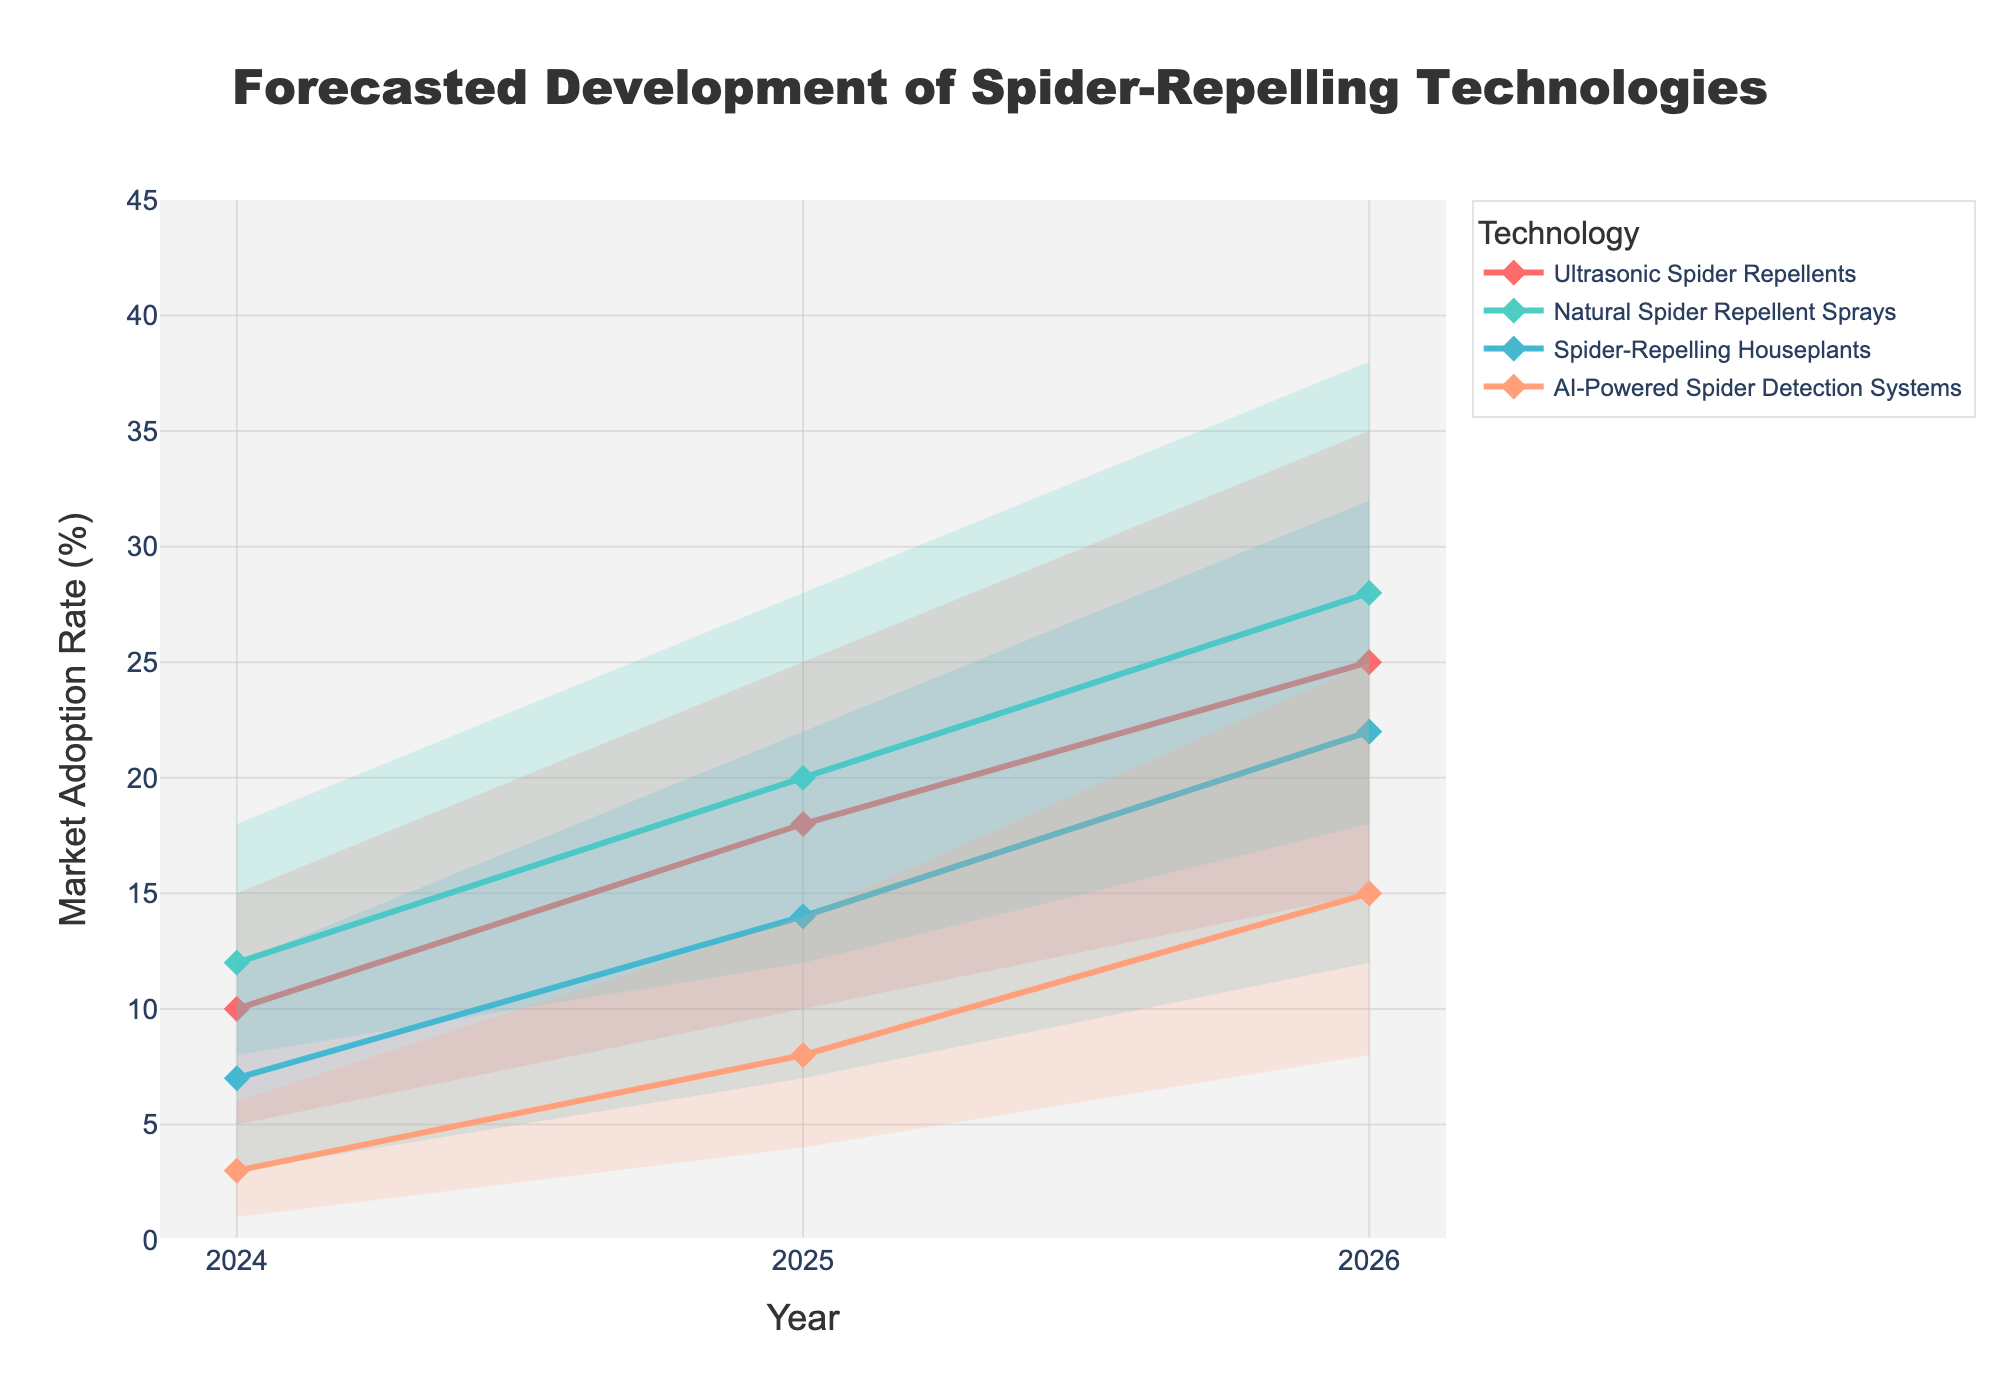What is the highest market adoption rate projected for Ultrasonic Spider Repellents in 2026? The highest market adoption rate for Ultrasonic Spider Repellents in 2026 corresponds to the "High Estimate" value for that technology in that year. From the data, this value is 35%.
Answer: 35% What is the range of market adoption rates for Spider-Repelling Houseplants in 2025? The range of market adoption rates is found by subtracting the Low Estimate from the High Estimate for Spider-Repelling Houseplants in 2025. The values are 22% (High Estimate) and 7% (Low Estimate). Thus, 22% - 7% = 15%.
Answer: 15% Which technology has the lowest Mid Estimate for market adoption in 2024? To determine which technology has the lowest Mid Estimate for market adoption in 2024, compare the Mid Estimates of all technologies in that year. AI-Powered Spider Detection Systems have a Mid Estimate of 3%, which is the lowest among the listed technologies.
Answer: AI-Powered Spider Detection Systems Between which two years does the Mid Estimate for Natural Spider Repellent Sprays show the greatest increase? Calculate the increase in Mid Estimates for Natural Spider Repellent Sprays between each pair of adjacent years: between 2024 and 2025 (20% - 12% = 8%) and between 2025 and 2026 (28% - 20% = 8%). The increase is the same for both intervals, 8%.
Answer: 2024 to 2025, and 2025 to 2026 Do any technologies have overlapping market adoption rate ranges in 2024? Check if the intervals of Low to High Estimates for any two technologies in 2024 overlap. Ultrasonic Spider Repellents (5% to 15%) and Natural Spider Repellent Sprays (8% to 18%) overlap, as do Spider-Repelling Houseplants (3% to 12%) and Natural Spider Repellent Sprays (8% to 18%).
Answer: Yes Which technology has the steepest projected increase in Mid Estimate from 2025 to 2026? Calculate the increase in Mid Estimates for each technology between 2025 and 2026. The values are as follows: Ultrasonic Spider Repellents (25% - 18% = 7%), Natural Spider Repellent Sprays (28% - 20% = 8%), Spider-Repelling Houseplants (22% - 14% = 8%), AI-Powered Spider Detection Systems (15% - 8% = 7%). Natural Spider Repellent Sprays and Spider-Repelling Houseplants both have the steepest increase of 8%.
Answer: Natural Spider Repellent Sprays, Spider-Repelling Houseplants What is the Mid Estimate for market adoption of AI-Powered Spider Detection Systems in 2025? Refer to the Mid Estimate for AI-Powered Spider Detection Systems in the year 2025 from the data. It is recorded as 8%.
Answer: 8% How many technologies have a projected market adoption rate of 20% or higher in 2026 according to their Mid Estimates? Compare the Mid Estimates of all technologies in 2026. Ultrasonic Spider Repellents (25%), Natural Spider Repellent Sprays (28%), and Spider-Repelling Houseplants (22%) are all 20% or higher.
Answer: 3 technologies 